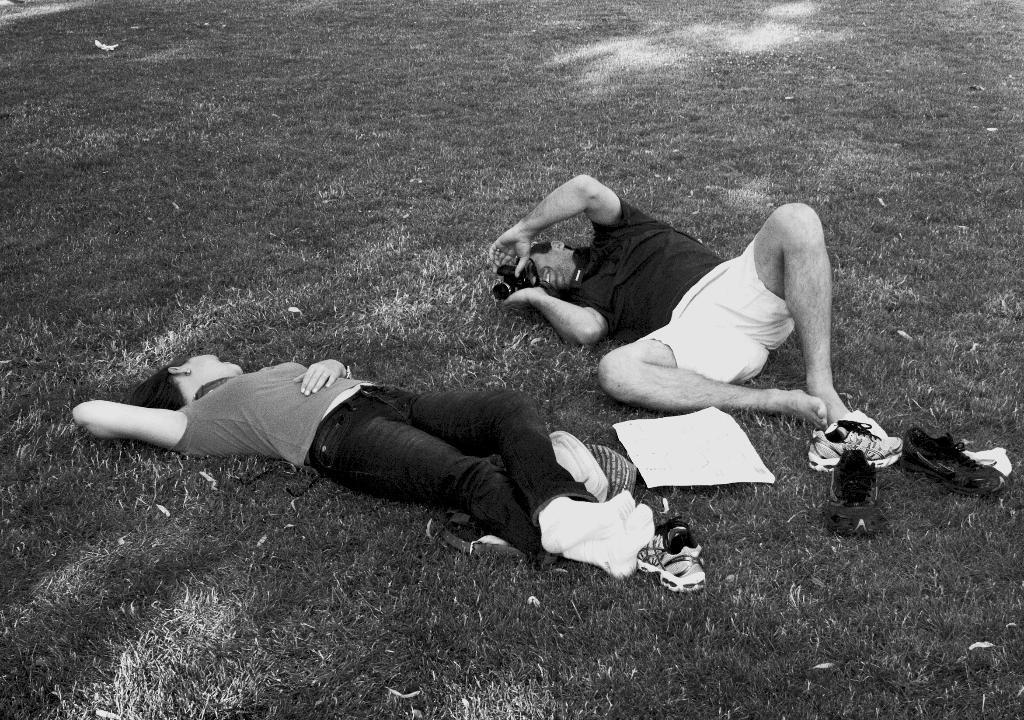What are the two persons in the image doing? The two persons are lying on the grass. Can you describe any objects related to the persons in the image? There are shoes visible in the image. What type of gun can be seen in the hands of one of the persons in the image? There is no gun present in the image; the persons are lying on the grass with their shoes visible. 